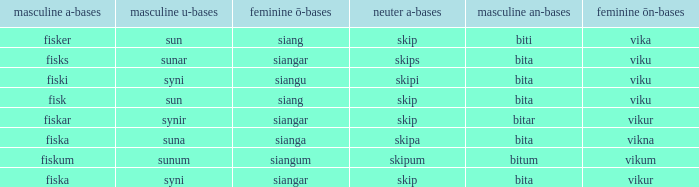What is the masculine u form for the old Swedish word with a neuter a form of skipum? Sunum. 